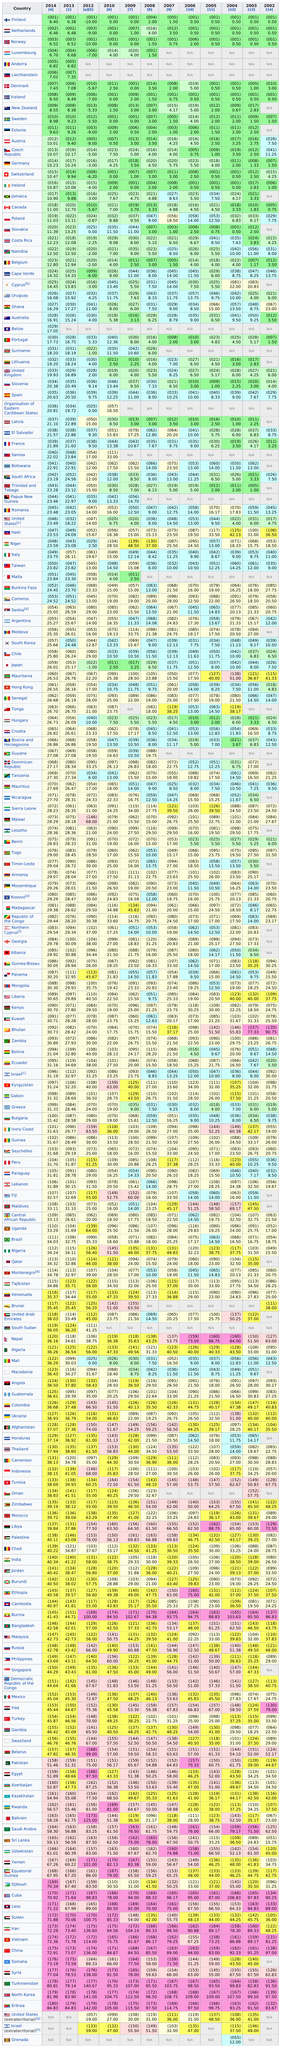List a handful of essential elements in this visual. The chart records 12 years. Brazil had a score of 0.92 in 2014, while Maldives had a score of 0.92 in 2014. The difference in score between the two countries in 2014 was 0.00. In 2014, Finland was ranked as the country with the highest level of press freedom, according to the press freedom index. Andorra has competed in a total of 2 years. Jamaica did not have a score in the year 2002. 